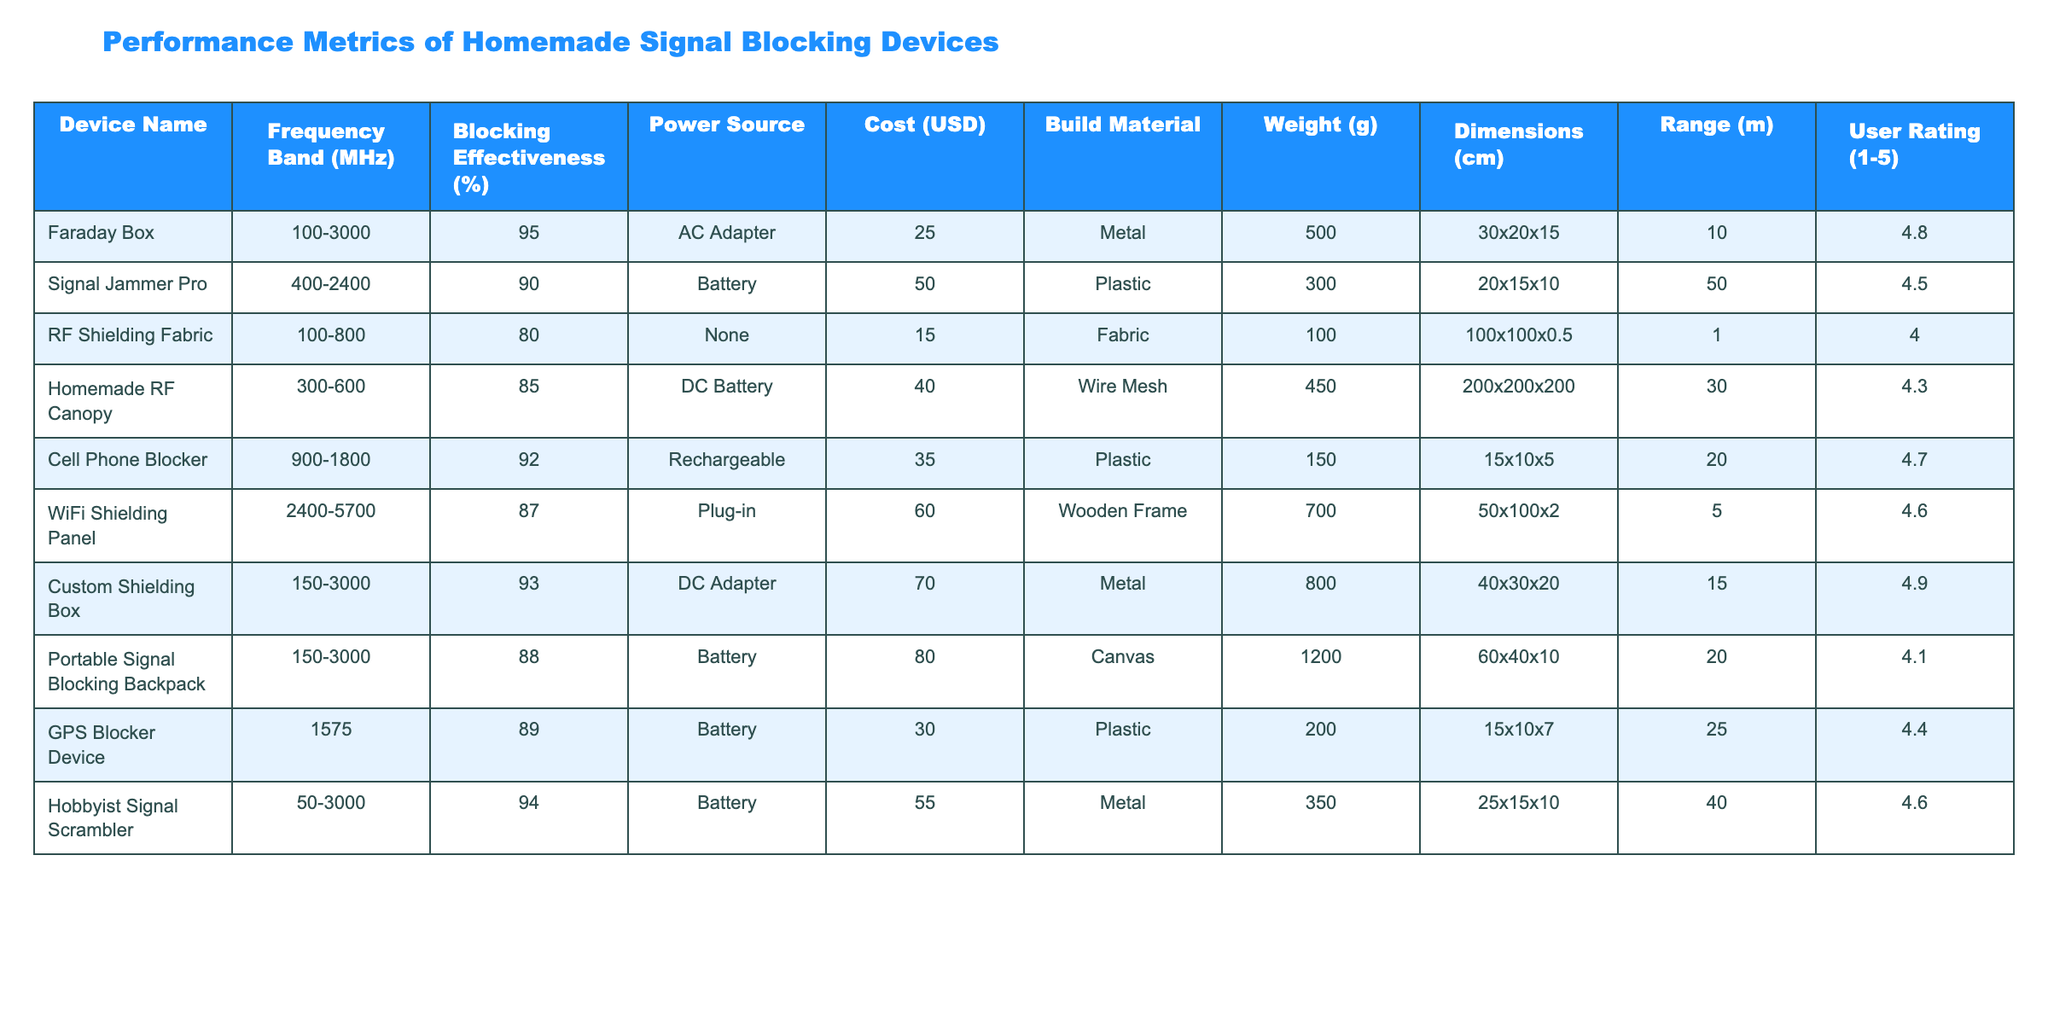What is the blocking effectiveness of the Homemade RF Canopy? According to the table, the Blocking Effectiveness of the Homemade RF Canopy is directly stated as 85%.
Answer: 85% Which device has the highest user rating? To find the device with the highest user rating, I scanned through the User Rating column and found the Custom Shielding Box with a rating of 4.9.
Answer: Custom Shielding Box What is the average cost of all the devices listed? To calculate the average cost, I sum up all the costs: (25 + 50 + 15 + 40 + 35 + 60 + 70 + 80 + 30 + 55) =  460, and then divide by the number of devices, which is 10. So, the average cost is 460/10 = 46.
Answer: 46 Is there any device that uses a fabric as a build material? Yes, according to the table, the RF Shielding Fabric uses fabric as its build material.
Answer: Yes Which device has the largest dimensions? The dimensions for each device are compared, and the Homemade RF Canopy, with dimensions of 200x200x200 cm, is the largest.
Answer: Homemade RF Canopy How many devices are powered by a battery? By reviewing the Power Source column, I count the devices that use a battery: Signal Jammer Pro, Homemade RF Canopy, Cell Phone Blocker, GPS Blocker Device, and Hobbyist Signal Scrambler, making a total of 5 devices.
Answer: 5 What is the weight difference between the heaviest and lightest device? The heaviest device is the Portable Signal Blocking Backpack at 1200 g and the lightest is RF Shielding Fabric at 100 g. The weight difference is 1200 - 100 = 1100 g.
Answer: 1100 g Are there any devices that are powered by AC adapters? Yes, according to the table, the Faraday Box and Custom Shielding Box are powered by AC adapters.
Answer: Yes Which two devices have the closest blocking effectiveness percentages? Checking the Blocking Effectiveness percentages, the WiFi Shielding Panel at 87% and the Homemade RF Canopy at 85% have the closest values, with a difference of only 2%.
Answer: 2% What is the total range in meters of the devices that have a blocking effectiveness greater than 90%? The devices with blocking effectiveness greater than 90% are: Faraday Box (10m), Cell Phone Blocker (20m), Custom Shielding Box (15m), and Hobbyist Signal Scrambler (40m). Adding their ranges gives: 10 + 20 + 15 + 40 = 85m.
Answer: 85 m 